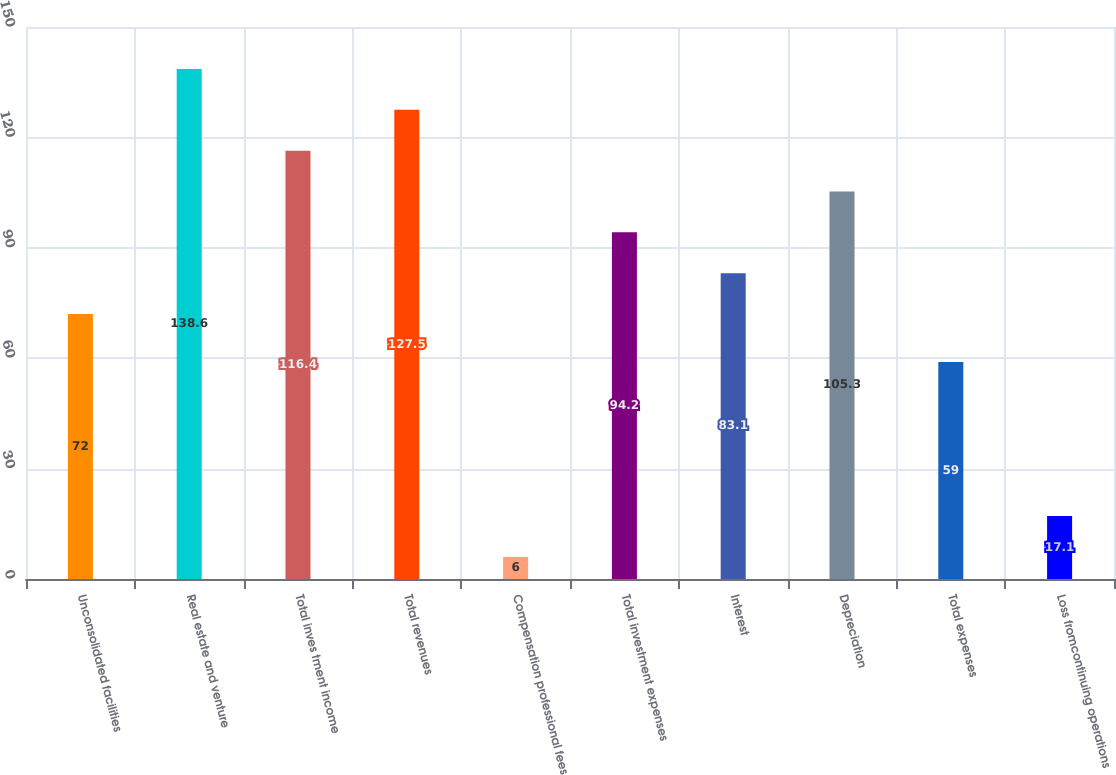Convert chart to OTSL. <chart><loc_0><loc_0><loc_500><loc_500><bar_chart><fcel>Unconsolidated facilities<fcel>Real estate and venture<fcel>Total inves tment income<fcel>Total revenues<fcel>Compensation professional fees<fcel>Total investment expenses<fcel>Interest<fcel>Depreciation<fcel>Total expenses<fcel>Loss fromcontinuing operations<nl><fcel>72<fcel>138.6<fcel>116.4<fcel>127.5<fcel>6<fcel>94.2<fcel>83.1<fcel>105.3<fcel>59<fcel>17.1<nl></chart> 